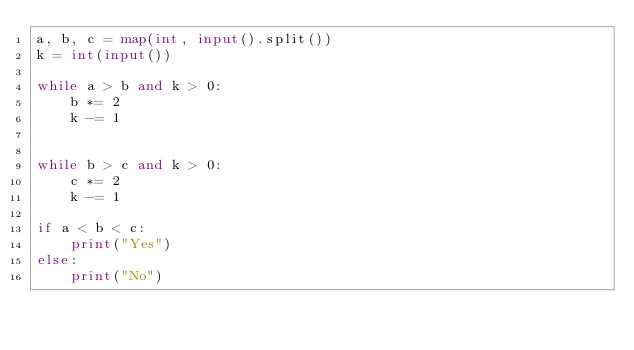<code> <loc_0><loc_0><loc_500><loc_500><_Python_>a, b, c = map(int, input().split())
k = int(input())

while a > b and k > 0:
    b *= 2
    k -= 1
    

while b > c and k > 0:
    c *= 2
    k -= 1

if a < b < c:
    print("Yes")
else:
    print("No")</code> 